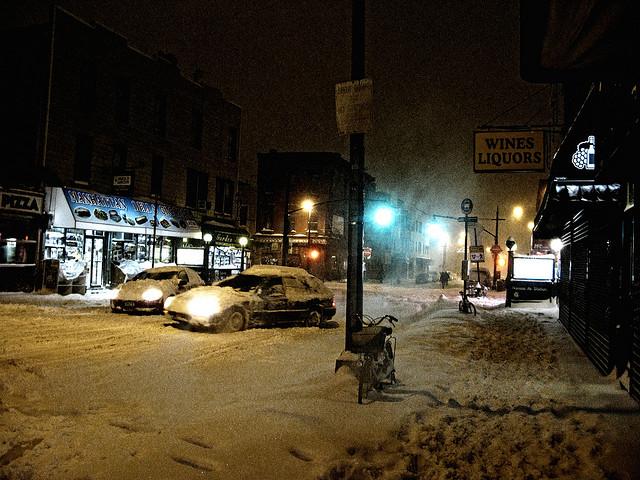What type of store is on the right?
Concise answer only. Liquor. What's happening in this picture?
Quick response, please. Snowing. Are the cars covered with snow?
Give a very brief answer. Yes. 